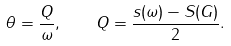<formula> <loc_0><loc_0><loc_500><loc_500>\theta = \frac { Q } { \omega } , \quad Q = \frac { s ( \omega ) - S ( G ) } { 2 } .</formula> 